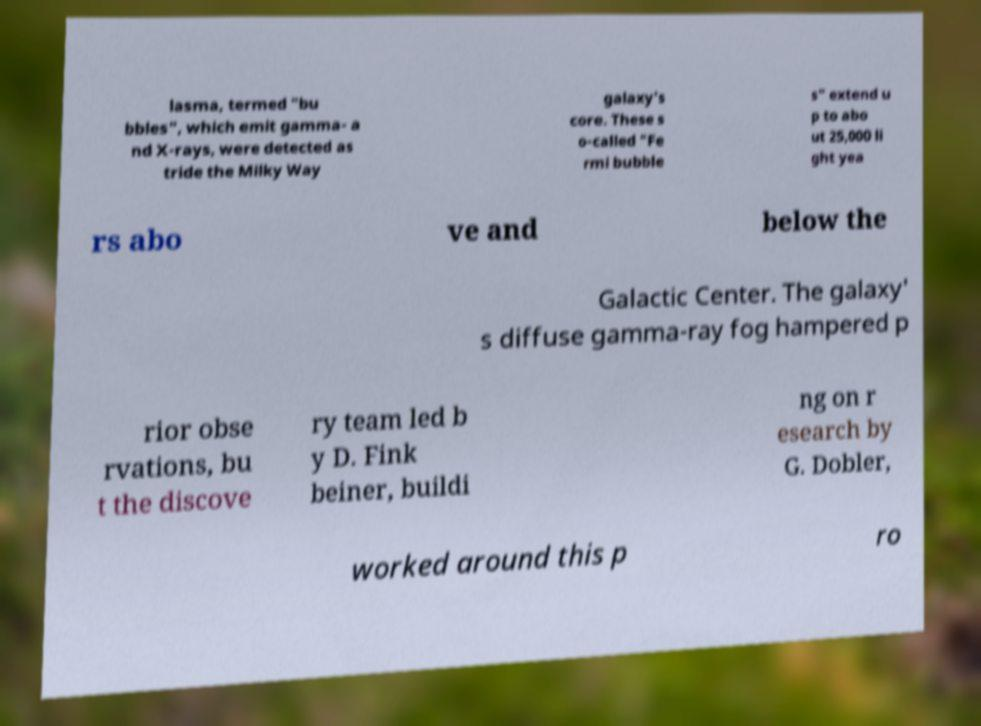For documentation purposes, I need the text within this image transcribed. Could you provide that? lasma, termed "bu bbles", which emit gamma- a nd X-rays, were detected as tride the Milky Way galaxy's core. These s o-called "Fe rmi bubble s" extend u p to abo ut 25,000 li ght yea rs abo ve and below the Galactic Center. The galaxy' s diffuse gamma-ray fog hampered p rior obse rvations, bu t the discove ry team led b y D. Fink beiner, buildi ng on r esearch by G. Dobler, worked around this p ro 